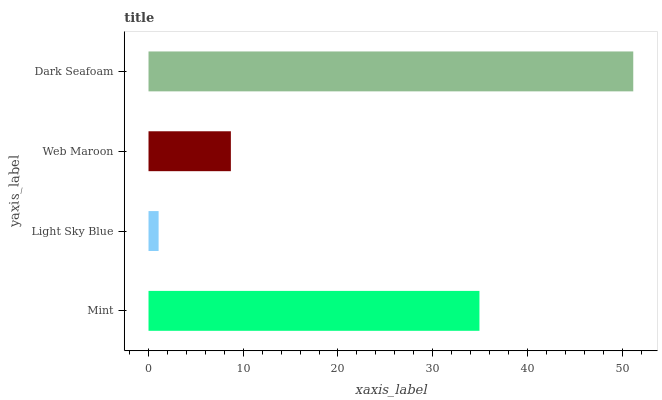Is Light Sky Blue the minimum?
Answer yes or no. Yes. Is Dark Seafoam the maximum?
Answer yes or no. Yes. Is Web Maroon the minimum?
Answer yes or no. No. Is Web Maroon the maximum?
Answer yes or no. No. Is Web Maroon greater than Light Sky Blue?
Answer yes or no. Yes. Is Light Sky Blue less than Web Maroon?
Answer yes or no. Yes. Is Light Sky Blue greater than Web Maroon?
Answer yes or no. No. Is Web Maroon less than Light Sky Blue?
Answer yes or no. No. Is Mint the high median?
Answer yes or no. Yes. Is Web Maroon the low median?
Answer yes or no. Yes. Is Light Sky Blue the high median?
Answer yes or no. No. Is Light Sky Blue the low median?
Answer yes or no. No. 